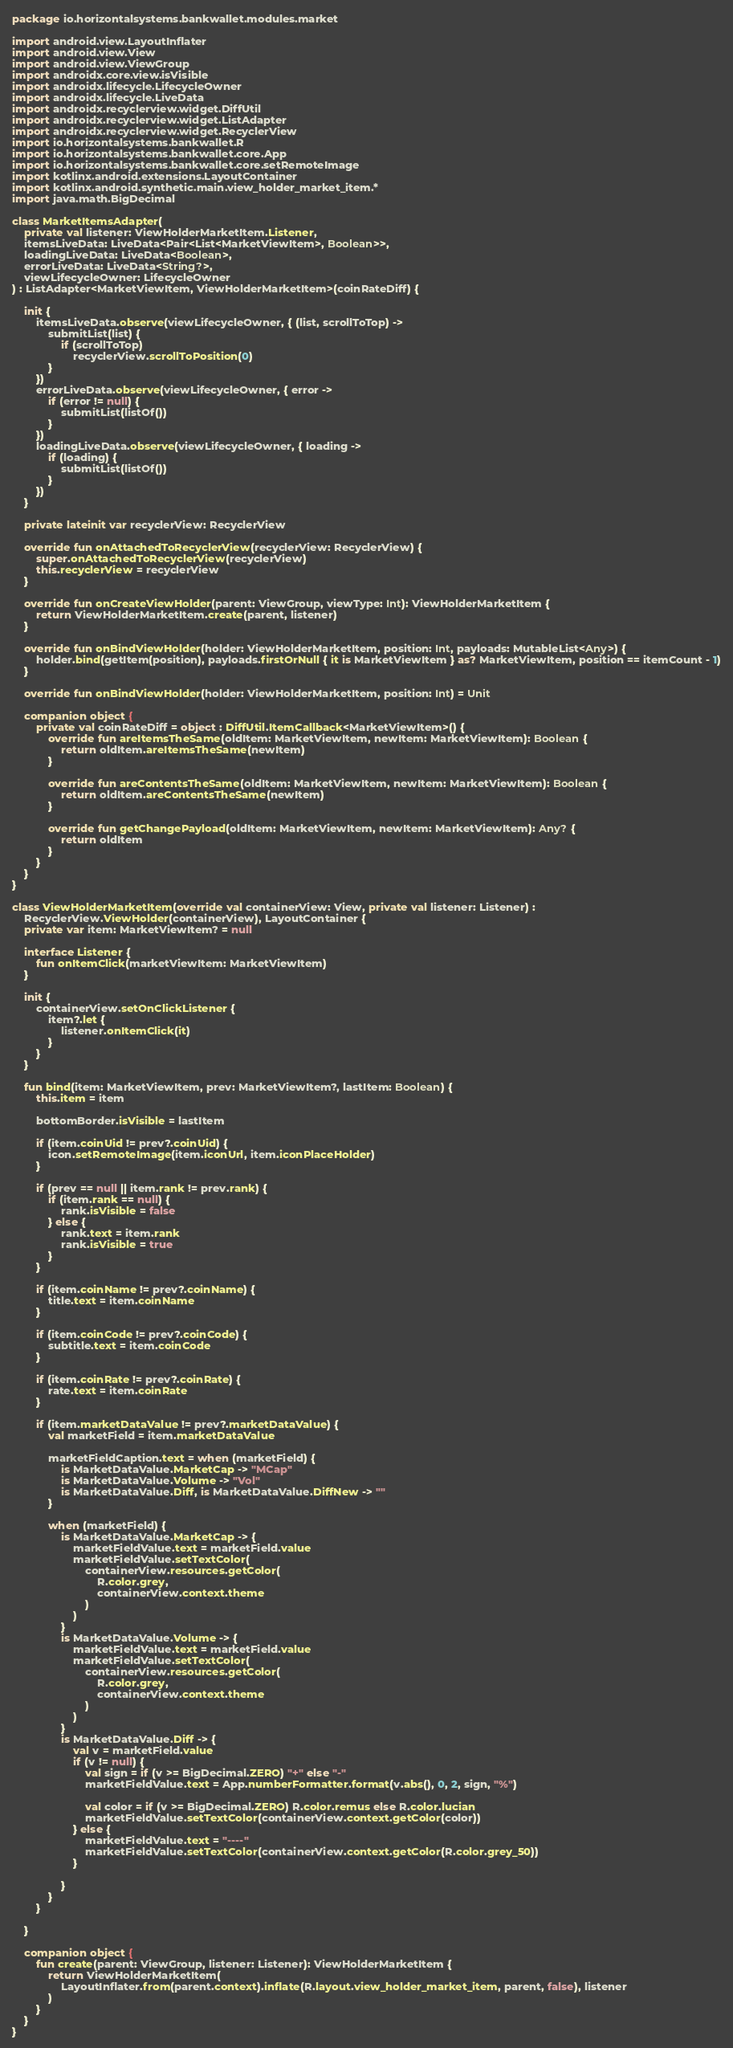<code> <loc_0><loc_0><loc_500><loc_500><_Kotlin_>package io.horizontalsystems.bankwallet.modules.market

import android.view.LayoutInflater
import android.view.View
import android.view.ViewGroup
import androidx.core.view.isVisible
import androidx.lifecycle.LifecycleOwner
import androidx.lifecycle.LiveData
import androidx.recyclerview.widget.DiffUtil
import androidx.recyclerview.widget.ListAdapter
import androidx.recyclerview.widget.RecyclerView
import io.horizontalsystems.bankwallet.R
import io.horizontalsystems.bankwallet.core.App
import io.horizontalsystems.bankwallet.core.setRemoteImage
import kotlinx.android.extensions.LayoutContainer
import kotlinx.android.synthetic.main.view_holder_market_item.*
import java.math.BigDecimal

class MarketItemsAdapter(
    private val listener: ViewHolderMarketItem.Listener,
    itemsLiveData: LiveData<Pair<List<MarketViewItem>, Boolean>>,
    loadingLiveData: LiveData<Boolean>,
    errorLiveData: LiveData<String?>,
    viewLifecycleOwner: LifecycleOwner
) : ListAdapter<MarketViewItem, ViewHolderMarketItem>(coinRateDiff) {

    init {
        itemsLiveData.observe(viewLifecycleOwner, { (list, scrollToTop) ->
            submitList(list) {
                if (scrollToTop)
                    recyclerView.scrollToPosition(0)
            }
        })
        errorLiveData.observe(viewLifecycleOwner, { error ->
            if (error != null) {
                submitList(listOf())
            }
        })
        loadingLiveData.observe(viewLifecycleOwner, { loading ->
            if (loading) {
                submitList(listOf())
            }
        })
    }

    private lateinit var recyclerView: RecyclerView

    override fun onAttachedToRecyclerView(recyclerView: RecyclerView) {
        super.onAttachedToRecyclerView(recyclerView)
        this.recyclerView = recyclerView
    }

    override fun onCreateViewHolder(parent: ViewGroup, viewType: Int): ViewHolderMarketItem {
        return ViewHolderMarketItem.create(parent, listener)
    }

    override fun onBindViewHolder(holder: ViewHolderMarketItem, position: Int, payloads: MutableList<Any>) {
        holder.bind(getItem(position), payloads.firstOrNull { it is MarketViewItem } as? MarketViewItem, position == itemCount - 1)
    }

    override fun onBindViewHolder(holder: ViewHolderMarketItem, position: Int) = Unit

    companion object {
        private val coinRateDiff = object : DiffUtil.ItemCallback<MarketViewItem>() {
            override fun areItemsTheSame(oldItem: MarketViewItem, newItem: MarketViewItem): Boolean {
                return oldItem.areItemsTheSame(newItem)
            }

            override fun areContentsTheSame(oldItem: MarketViewItem, newItem: MarketViewItem): Boolean {
                return oldItem.areContentsTheSame(newItem)
            }

            override fun getChangePayload(oldItem: MarketViewItem, newItem: MarketViewItem): Any? {
                return oldItem
            }
        }
    }
}

class ViewHolderMarketItem(override val containerView: View, private val listener: Listener) :
    RecyclerView.ViewHolder(containerView), LayoutContainer {
    private var item: MarketViewItem? = null

    interface Listener {
        fun onItemClick(marketViewItem: MarketViewItem)
    }

    init {
        containerView.setOnClickListener {
            item?.let {
                listener.onItemClick(it)
            }
        }
    }

    fun bind(item: MarketViewItem, prev: MarketViewItem?, lastItem: Boolean) {
        this.item = item

        bottomBorder.isVisible = lastItem

        if (item.coinUid != prev?.coinUid) {
            icon.setRemoteImage(item.iconUrl, item.iconPlaceHolder)
        }

        if (prev == null || item.rank != prev.rank) {
            if (item.rank == null) {
                rank.isVisible = false
            } else {
                rank.text = item.rank
                rank.isVisible = true
            }
        }

        if (item.coinName != prev?.coinName) {
            title.text = item.coinName
        }

        if (item.coinCode != prev?.coinCode) {
            subtitle.text = item.coinCode
        }

        if (item.coinRate != prev?.coinRate) {
            rate.text = item.coinRate
        }

        if (item.marketDataValue != prev?.marketDataValue) {
            val marketField = item.marketDataValue

            marketFieldCaption.text = when (marketField) {
                is MarketDataValue.MarketCap -> "MCap"
                is MarketDataValue.Volume -> "Vol"
                is MarketDataValue.Diff, is MarketDataValue.DiffNew -> ""
            }

            when (marketField) {
                is MarketDataValue.MarketCap -> {
                    marketFieldValue.text = marketField.value
                    marketFieldValue.setTextColor(
                        containerView.resources.getColor(
                            R.color.grey,
                            containerView.context.theme
                        )
                    )
                }
                is MarketDataValue.Volume -> {
                    marketFieldValue.text = marketField.value
                    marketFieldValue.setTextColor(
                        containerView.resources.getColor(
                            R.color.grey,
                            containerView.context.theme
                        )
                    )
                }
                is MarketDataValue.Diff -> {
                    val v = marketField.value
                    if (v != null) {
                        val sign = if (v >= BigDecimal.ZERO) "+" else "-"
                        marketFieldValue.text = App.numberFormatter.format(v.abs(), 0, 2, sign, "%")

                        val color = if (v >= BigDecimal.ZERO) R.color.remus else R.color.lucian
                        marketFieldValue.setTextColor(containerView.context.getColor(color))
                    } else {
                        marketFieldValue.text = "----"
                        marketFieldValue.setTextColor(containerView.context.getColor(R.color.grey_50))
                    }

                }
            }
        }

    }

    companion object {
        fun create(parent: ViewGroup, listener: Listener): ViewHolderMarketItem {
            return ViewHolderMarketItem(
                LayoutInflater.from(parent.context).inflate(R.layout.view_holder_market_item, parent, false), listener
            )
        }
    }
}
</code> 